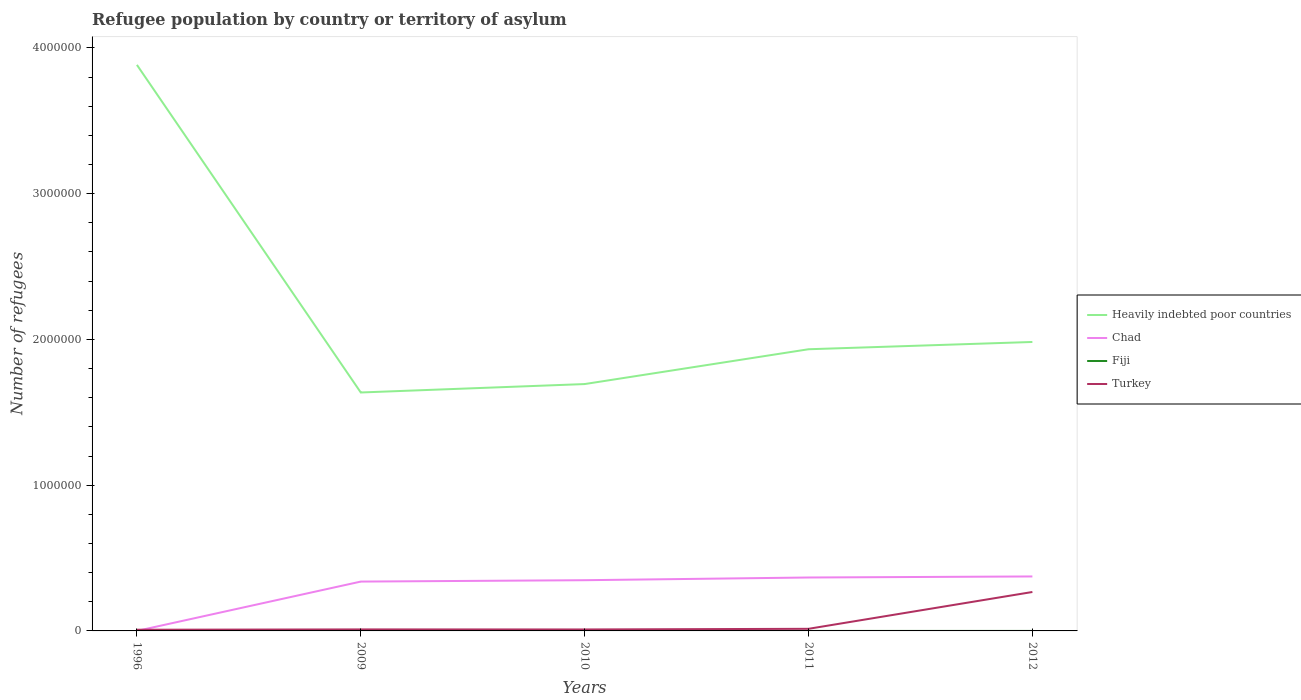How many different coloured lines are there?
Keep it short and to the point. 4. Does the line corresponding to Turkey intersect with the line corresponding to Heavily indebted poor countries?
Make the answer very short. No. Is the number of lines equal to the number of legend labels?
Your response must be concise. Yes. In which year was the number of refugees in Heavily indebted poor countries maximum?
Offer a terse response. 2009. What is the total number of refugees in Chad in the graph?
Your answer should be compact. -2.80e+04. What is the difference between the highest and the second highest number of refugees in Chad?
Keep it short and to the point. 3.74e+05. What is the difference between the highest and the lowest number of refugees in Chad?
Give a very brief answer. 4. Is the number of refugees in Fiji strictly greater than the number of refugees in Heavily indebted poor countries over the years?
Provide a short and direct response. Yes. How many lines are there?
Keep it short and to the point. 4. How many years are there in the graph?
Offer a very short reply. 5. Does the graph contain any zero values?
Give a very brief answer. No. Where does the legend appear in the graph?
Make the answer very short. Center right. How many legend labels are there?
Ensure brevity in your answer.  4. What is the title of the graph?
Offer a very short reply. Refugee population by country or territory of asylum. Does "Burkina Faso" appear as one of the legend labels in the graph?
Make the answer very short. No. What is the label or title of the Y-axis?
Your response must be concise. Number of refugees. What is the Number of refugees of Heavily indebted poor countries in 1996?
Your response must be concise. 3.88e+06. What is the Number of refugees in Fiji in 1996?
Your response must be concise. 9. What is the Number of refugees in Turkey in 1996?
Offer a very short reply. 8166. What is the Number of refugees in Heavily indebted poor countries in 2009?
Provide a short and direct response. 1.64e+06. What is the Number of refugees in Chad in 2009?
Offer a very short reply. 3.38e+05. What is the Number of refugees in Fiji in 2009?
Offer a terse response. 2. What is the Number of refugees of Turkey in 2009?
Your answer should be very brief. 1.04e+04. What is the Number of refugees of Heavily indebted poor countries in 2010?
Your response must be concise. 1.69e+06. What is the Number of refugees of Chad in 2010?
Your response must be concise. 3.48e+05. What is the Number of refugees in Turkey in 2010?
Make the answer very short. 1.00e+04. What is the Number of refugees of Heavily indebted poor countries in 2011?
Keep it short and to the point. 1.93e+06. What is the Number of refugees in Chad in 2011?
Give a very brief answer. 3.66e+05. What is the Number of refugees of Fiji in 2011?
Your answer should be compact. 7. What is the Number of refugees of Turkey in 2011?
Provide a succinct answer. 1.45e+04. What is the Number of refugees in Heavily indebted poor countries in 2012?
Keep it short and to the point. 1.98e+06. What is the Number of refugees of Chad in 2012?
Ensure brevity in your answer.  3.74e+05. What is the Number of refugees of Fiji in 2012?
Make the answer very short. 6. What is the Number of refugees in Turkey in 2012?
Offer a terse response. 2.67e+05. Across all years, what is the maximum Number of refugees in Heavily indebted poor countries?
Offer a very short reply. 3.88e+06. Across all years, what is the maximum Number of refugees of Chad?
Offer a very short reply. 3.74e+05. Across all years, what is the maximum Number of refugees in Turkey?
Provide a short and direct response. 2.67e+05. Across all years, what is the minimum Number of refugees of Heavily indebted poor countries?
Provide a succinct answer. 1.64e+06. Across all years, what is the minimum Number of refugees of Chad?
Give a very brief answer. 100. Across all years, what is the minimum Number of refugees in Turkey?
Ensure brevity in your answer.  8166. What is the total Number of refugees in Heavily indebted poor countries in the graph?
Keep it short and to the point. 1.11e+07. What is the total Number of refugees in Chad in the graph?
Your answer should be compact. 1.43e+06. What is the total Number of refugees in Turkey in the graph?
Your response must be concise. 3.10e+05. What is the difference between the Number of refugees in Heavily indebted poor countries in 1996 and that in 2009?
Provide a succinct answer. 2.25e+06. What is the difference between the Number of refugees of Chad in 1996 and that in 2009?
Your answer should be compact. -3.38e+05. What is the difference between the Number of refugees of Fiji in 1996 and that in 2009?
Offer a very short reply. 7. What is the difference between the Number of refugees of Turkey in 1996 and that in 2009?
Make the answer very short. -2184. What is the difference between the Number of refugees of Heavily indebted poor countries in 1996 and that in 2010?
Give a very brief answer. 2.19e+06. What is the difference between the Number of refugees of Chad in 1996 and that in 2010?
Your answer should be very brief. -3.48e+05. What is the difference between the Number of refugees in Turkey in 1996 and that in 2010?
Offer a terse response. -1866. What is the difference between the Number of refugees of Heavily indebted poor countries in 1996 and that in 2011?
Offer a terse response. 1.95e+06. What is the difference between the Number of refugees of Chad in 1996 and that in 2011?
Offer a very short reply. -3.66e+05. What is the difference between the Number of refugees of Fiji in 1996 and that in 2011?
Ensure brevity in your answer.  2. What is the difference between the Number of refugees in Turkey in 1996 and that in 2011?
Your response must be concise. -6299. What is the difference between the Number of refugees of Heavily indebted poor countries in 1996 and that in 2012?
Give a very brief answer. 1.90e+06. What is the difference between the Number of refugees in Chad in 1996 and that in 2012?
Give a very brief answer. -3.74e+05. What is the difference between the Number of refugees of Turkey in 1996 and that in 2012?
Provide a succinct answer. -2.59e+05. What is the difference between the Number of refugees in Heavily indebted poor countries in 2009 and that in 2010?
Your answer should be compact. -5.78e+04. What is the difference between the Number of refugees in Chad in 2009 and that in 2010?
Offer a terse response. -9444. What is the difference between the Number of refugees of Turkey in 2009 and that in 2010?
Provide a succinct answer. 318. What is the difference between the Number of refugees in Heavily indebted poor countries in 2009 and that in 2011?
Give a very brief answer. -2.97e+05. What is the difference between the Number of refugees in Chad in 2009 and that in 2011?
Provide a short and direct response. -2.80e+04. What is the difference between the Number of refugees of Turkey in 2009 and that in 2011?
Your answer should be compact. -4115. What is the difference between the Number of refugees in Heavily indebted poor countries in 2009 and that in 2012?
Ensure brevity in your answer.  -3.47e+05. What is the difference between the Number of refugees in Chad in 2009 and that in 2012?
Ensure brevity in your answer.  -3.52e+04. What is the difference between the Number of refugees in Turkey in 2009 and that in 2012?
Make the answer very short. -2.57e+05. What is the difference between the Number of refugees of Heavily indebted poor countries in 2010 and that in 2011?
Ensure brevity in your answer.  -2.39e+05. What is the difference between the Number of refugees in Chad in 2010 and that in 2011?
Ensure brevity in your answer.  -1.86e+04. What is the difference between the Number of refugees in Fiji in 2010 and that in 2011?
Your response must be concise. -6. What is the difference between the Number of refugees of Turkey in 2010 and that in 2011?
Your answer should be very brief. -4433. What is the difference between the Number of refugees in Heavily indebted poor countries in 2010 and that in 2012?
Your response must be concise. -2.89e+05. What is the difference between the Number of refugees in Chad in 2010 and that in 2012?
Give a very brief answer. -2.58e+04. What is the difference between the Number of refugees of Fiji in 2010 and that in 2012?
Offer a terse response. -5. What is the difference between the Number of refugees of Turkey in 2010 and that in 2012?
Keep it short and to the point. -2.57e+05. What is the difference between the Number of refugees of Heavily indebted poor countries in 2011 and that in 2012?
Offer a terse response. -5.00e+04. What is the difference between the Number of refugees of Chad in 2011 and that in 2012?
Your response must be concise. -7201. What is the difference between the Number of refugees of Turkey in 2011 and that in 2012?
Your response must be concise. -2.53e+05. What is the difference between the Number of refugees in Heavily indebted poor countries in 1996 and the Number of refugees in Chad in 2009?
Make the answer very short. 3.54e+06. What is the difference between the Number of refugees in Heavily indebted poor countries in 1996 and the Number of refugees in Fiji in 2009?
Offer a very short reply. 3.88e+06. What is the difference between the Number of refugees in Heavily indebted poor countries in 1996 and the Number of refugees in Turkey in 2009?
Your answer should be compact. 3.87e+06. What is the difference between the Number of refugees in Chad in 1996 and the Number of refugees in Fiji in 2009?
Offer a very short reply. 98. What is the difference between the Number of refugees in Chad in 1996 and the Number of refugees in Turkey in 2009?
Give a very brief answer. -1.02e+04. What is the difference between the Number of refugees in Fiji in 1996 and the Number of refugees in Turkey in 2009?
Give a very brief answer. -1.03e+04. What is the difference between the Number of refugees of Heavily indebted poor countries in 1996 and the Number of refugees of Chad in 2010?
Your answer should be very brief. 3.54e+06. What is the difference between the Number of refugees of Heavily indebted poor countries in 1996 and the Number of refugees of Fiji in 2010?
Make the answer very short. 3.88e+06. What is the difference between the Number of refugees in Heavily indebted poor countries in 1996 and the Number of refugees in Turkey in 2010?
Ensure brevity in your answer.  3.87e+06. What is the difference between the Number of refugees in Chad in 1996 and the Number of refugees in Fiji in 2010?
Your response must be concise. 99. What is the difference between the Number of refugees in Chad in 1996 and the Number of refugees in Turkey in 2010?
Provide a short and direct response. -9932. What is the difference between the Number of refugees in Fiji in 1996 and the Number of refugees in Turkey in 2010?
Provide a succinct answer. -1.00e+04. What is the difference between the Number of refugees in Heavily indebted poor countries in 1996 and the Number of refugees in Chad in 2011?
Offer a very short reply. 3.52e+06. What is the difference between the Number of refugees in Heavily indebted poor countries in 1996 and the Number of refugees in Fiji in 2011?
Keep it short and to the point. 3.88e+06. What is the difference between the Number of refugees in Heavily indebted poor countries in 1996 and the Number of refugees in Turkey in 2011?
Your answer should be very brief. 3.87e+06. What is the difference between the Number of refugees in Chad in 1996 and the Number of refugees in Fiji in 2011?
Provide a succinct answer. 93. What is the difference between the Number of refugees of Chad in 1996 and the Number of refugees of Turkey in 2011?
Ensure brevity in your answer.  -1.44e+04. What is the difference between the Number of refugees of Fiji in 1996 and the Number of refugees of Turkey in 2011?
Provide a short and direct response. -1.45e+04. What is the difference between the Number of refugees of Heavily indebted poor countries in 1996 and the Number of refugees of Chad in 2012?
Ensure brevity in your answer.  3.51e+06. What is the difference between the Number of refugees in Heavily indebted poor countries in 1996 and the Number of refugees in Fiji in 2012?
Ensure brevity in your answer.  3.88e+06. What is the difference between the Number of refugees of Heavily indebted poor countries in 1996 and the Number of refugees of Turkey in 2012?
Provide a succinct answer. 3.62e+06. What is the difference between the Number of refugees of Chad in 1996 and the Number of refugees of Fiji in 2012?
Your answer should be very brief. 94. What is the difference between the Number of refugees of Chad in 1996 and the Number of refugees of Turkey in 2012?
Provide a succinct answer. -2.67e+05. What is the difference between the Number of refugees in Fiji in 1996 and the Number of refugees in Turkey in 2012?
Keep it short and to the point. -2.67e+05. What is the difference between the Number of refugees of Heavily indebted poor countries in 2009 and the Number of refugees of Chad in 2010?
Ensure brevity in your answer.  1.29e+06. What is the difference between the Number of refugees in Heavily indebted poor countries in 2009 and the Number of refugees in Fiji in 2010?
Make the answer very short. 1.64e+06. What is the difference between the Number of refugees of Heavily indebted poor countries in 2009 and the Number of refugees of Turkey in 2010?
Keep it short and to the point. 1.63e+06. What is the difference between the Number of refugees in Chad in 2009 and the Number of refugees in Fiji in 2010?
Your answer should be compact. 3.38e+05. What is the difference between the Number of refugees in Chad in 2009 and the Number of refugees in Turkey in 2010?
Provide a succinct answer. 3.28e+05. What is the difference between the Number of refugees of Fiji in 2009 and the Number of refugees of Turkey in 2010?
Make the answer very short. -1.00e+04. What is the difference between the Number of refugees of Heavily indebted poor countries in 2009 and the Number of refugees of Chad in 2011?
Make the answer very short. 1.27e+06. What is the difference between the Number of refugees in Heavily indebted poor countries in 2009 and the Number of refugees in Fiji in 2011?
Your response must be concise. 1.64e+06. What is the difference between the Number of refugees in Heavily indebted poor countries in 2009 and the Number of refugees in Turkey in 2011?
Provide a short and direct response. 1.62e+06. What is the difference between the Number of refugees of Chad in 2009 and the Number of refugees of Fiji in 2011?
Provide a succinct answer. 3.38e+05. What is the difference between the Number of refugees of Chad in 2009 and the Number of refugees of Turkey in 2011?
Offer a terse response. 3.24e+05. What is the difference between the Number of refugees in Fiji in 2009 and the Number of refugees in Turkey in 2011?
Offer a very short reply. -1.45e+04. What is the difference between the Number of refugees in Heavily indebted poor countries in 2009 and the Number of refugees in Chad in 2012?
Make the answer very short. 1.26e+06. What is the difference between the Number of refugees of Heavily indebted poor countries in 2009 and the Number of refugees of Fiji in 2012?
Ensure brevity in your answer.  1.64e+06. What is the difference between the Number of refugees in Heavily indebted poor countries in 2009 and the Number of refugees in Turkey in 2012?
Provide a short and direct response. 1.37e+06. What is the difference between the Number of refugees in Chad in 2009 and the Number of refugees in Fiji in 2012?
Offer a terse response. 3.38e+05. What is the difference between the Number of refugees in Chad in 2009 and the Number of refugees in Turkey in 2012?
Offer a very short reply. 7.14e+04. What is the difference between the Number of refugees of Fiji in 2009 and the Number of refugees of Turkey in 2012?
Make the answer very short. -2.67e+05. What is the difference between the Number of refugees of Heavily indebted poor countries in 2010 and the Number of refugees of Chad in 2011?
Offer a terse response. 1.33e+06. What is the difference between the Number of refugees in Heavily indebted poor countries in 2010 and the Number of refugees in Fiji in 2011?
Your response must be concise. 1.69e+06. What is the difference between the Number of refugees in Heavily indebted poor countries in 2010 and the Number of refugees in Turkey in 2011?
Make the answer very short. 1.68e+06. What is the difference between the Number of refugees of Chad in 2010 and the Number of refugees of Fiji in 2011?
Offer a very short reply. 3.48e+05. What is the difference between the Number of refugees in Chad in 2010 and the Number of refugees in Turkey in 2011?
Provide a succinct answer. 3.33e+05. What is the difference between the Number of refugees of Fiji in 2010 and the Number of refugees of Turkey in 2011?
Your answer should be very brief. -1.45e+04. What is the difference between the Number of refugees of Heavily indebted poor countries in 2010 and the Number of refugees of Chad in 2012?
Your response must be concise. 1.32e+06. What is the difference between the Number of refugees of Heavily indebted poor countries in 2010 and the Number of refugees of Fiji in 2012?
Make the answer very short. 1.69e+06. What is the difference between the Number of refugees of Heavily indebted poor countries in 2010 and the Number of refugees of Turkey in 2012?
Ensure brevity in your answer.  1.43e+06. What is the difference between the Number of refugees in Chad in 2010 and the Number of refugees in Fiji in 2012?
Provide a short and direct response. 3.48e+05. What is the difference between the Number of refugees of Chad in 2010 and the Number of refugees of Turkey in 2012?
Make the answer very short. 8.09e+04. What is the difference between the Number of refugees in Fiji in 2010 and the Number of refugees in Turkey in 2012?
Keep it short and to the point. -2.67e+05. What is the difference between the Number of refugees in Heavily indebted poor countries in 2011 and the Number of refugees in Chad in 2012?
Ensure brevity in your answer.  1.56e+06. What is the difference between the Number of refugees in Heavily indebted poor countries in 2011 and the Number of refugees in Fiji in 2012?
Offer a very short reply. 1.93e+06. What is the difference between the Number of refugees of Heavily indebted poor countries in 2011 and the Number of refugees of Turkey in 2012?
Offer a terse response. 1.67e+06. What is the difference between the Number of refugees in Chad in 2011 and the Number of refugees in Fiji in 2012?
Your response must be concise. 3.66e+05. What is the difference between the Number of refugees of Chad in 2011 and the Number of refugees of Turkey in 2012?
Offer a very short reply. 9.94e+04. What is the difference between the Number of refugees in Fiji in 2011 and the Number of refugees in Turkey in 2012?
Provide a succinct answer. -2.67e+05. What is the average Number of refugees in Heavily indebted poor countries per year?
Your response must be concise. 2.23e+06. What is the average Number of refugees in Chad per year?
Make the answer very short. 2.85e+05. What is the average Number of refugees in Turkey per year?
Your answer should be very brief. 6.20e+04. In the year 1996, what is the difference between the Number of refugees in Heavily indebted poor countries and Number of refugees in Chad?
Your answer should be compact. 3.88e+06. In the year 1996, what is the difference between the Number of refugees in Heavily indebted poor countries and Number of refugees in Fiji?
Keep it short and to the point. 3.88e+06. In the year 1996, what is the difference between the Number of refugees in Heavily indebted poor countries and Number of refugees in Turkey?
Provide a succinct answer. 3.88e+06. In the year 1996, what is the difference between the Number of refugees in Chad and Number of refugees in Fiji?
Give a very brief answer. 91. In the year 1996, what is the difference between the Number of refugees of Chad and Number of refugees of Turkey?
Give a very brief answer. -8066. In the year 1996, what is the difference between the Number of refugees of Fiji and Number of refugees of Turkey?
Provide a short and direct response. -8157. In the year 2009, what is the difference between the Number of refugees of Heavily indebted poor countries and Number of refugees of Chad?
Your response must be concise. 1.30e+06. In the year 2009, what is the difference between the Number of refugees in Heavily indebted poor countries and Number of refugees in Fiji?
Your response must be concise. 1.64e+06. In the year 2009, what is the difference between the Number of refugees in Heavily indebted poor countries and Number of refugees in Turkey?
Make the answer very short. 1.63e+06. In the year 2009, what is the difference between the Number of refugees in Chad and Number of refugees in Fiji?
Provide a short and direct response. 3.38e+05. In the year 2009, what is the difference between the Number of refugees in Chad and Number of refugees in Turkey?
Your response must be concise. 3.28e+05. In the year 2009, what is the difference between the Number of refugees in Fiji and Number of refugees in Turkey?
Offer a very short reply. -1.03e+04. In the year 2010, what is the difference between the Number of refugees of Heavily indebted poor countries and Number of refugees of Chad?
Your response must be concise. 1.35e+06. In the year 2010, what is the difference between the Number of refugees in Heavily indebted poor countries and Number of refugees in Fiji?
Give a very brief answer. 1.69e+06. In the year 2010, what is the difference between the Number of refugees of Heavily indebted poor countries and Number of refugees of Turkey?
Offer a terse response. 1.68e+06. In the year 2010, what is the difference between the Number of refugees of Chad and Number of refugees of Fiji?
Ensure brevity in your answer.  3.48e+05. In the year 2010, what is the difference between the Number of refugees of Chad and Number of refugees of Turkey?
Make the answer very short. 3.38e+05. In the year 2010, what is the difference between the Number of refugees of Fiji and Number of refugees of Turkey?
Offer a very short reply. -1.00e+04. In the year 2011, what is the difference between the Number of refugees of Heavily indebted poor countries and Number of refugees of Chad?
Offer a terse response. 1.57e+06. In the year 2011, what is the difference between the Number of refugees in Heavily indebted poor countries and Number of refugees in Fiji?
Provide a short and direct response. 1.93e+06. In the year 2011, what is the difference between the Number of refugees of Heavily indebted poor countries and Number of refugees of Turkey?
Your answer should be very brief. 1.92e+06. In the year 2011, what is the difference between the Number of refugees in Chad and Number of refugees in Fiji?
Provide a short and direct response. 3.66e+05. In the year 2011, what is the difference between the Number of refugees of Chad and Number of refugees of Turkey?
Ensure brevity in your answer.  3.52e+05. In the year 2011, what is the difference between the Number of refugees in Fiji and Number of refugees in Turkey?
Provide a short and direct response. -1.45e+04. In the year 2012, what is the difference between the Number of refugees of Heavily indebted poor countries and Number of refugees of Chad?
Ensure brevity in your answer.  1.61e+06. In the year 2012, what is the difference between the Number of refugees of Heavily indebted poor countries and Number of refugees of Fiji?
Offer a very short reply. 1.98e+06. In the year 2012, what is the difference between the Number of refugees in Heavily indebted poor countries and Number of refugees in Turkey?
Ensure brevity in your answer.  1.72e+06. In the year 2012, what is the difference between the Number of refugees in Chad and Number of refugees in Fiji?
Provide a succinct answer. 3.74e+05. In the year 2012, what is the difference between the Number of refugees of Chad and Number of refugees of Turkey?
Your answer should be compact. 1.07e+05. In the year 2012, what is the difference between the Number of refugees in Fiji and Number of refugees in Turkey?
Offer a terse response. -2.67e+05. What is the ratio of the Number of refugees in Heavily indebted poor countries in 1996 to that in 2009?
Make the answer very short. 2.37. What is the ratio of the Number of refugees of Chad in 1996 to that in 2009?
Provide a succinct answer. 0. What is the ratio of the Number of refugees of Turkey in 1996 to that in 2009?
Ensure brevity in your answer.  0.79. What is the ratio of the Number of refugees of Heavily indebted poor countries in 1996 to that in 2010?
Offer a very short reply. 2.29. What is the ratio of the Number of refugees of Fiji in 1996 to that in 2010?
Make the answer very short. 9. What is the ratio of the Number of refugees in Turkey in 1996 to that in 2010?
Ensure brevity in your answer.  0.81. What is the ratio of the Number of refugees of Heavily indebted poor countries in 1996 to that in 2011?
Your response must be concise. 2.01. What is the ratio of the Number of refugees in Chad in 1996 to that in 2011?
Make the answer very short. 0. What is the ratio of the Number of refugees in Turkey in 1996 to that in 2011?
Keep it short and to the point. 0.56. What is the ratio of the Number of refugees in Heavily indebted poor countries in 1996 to that in 2012?
Make the answer very short. 1.96. What is the ratio of the Number of refugees of Turkey in 1996 to that in 2012?
Ensure brevity in your answer.  0.03. What is the ratio of the Number of refugees of Heavily indebted poor countries in 2009 to that in 2010?
Ensure brevity in your answer.  0.97. What is the ratio of the Number of refugees of Chad in 2009 to that in 2010?
Make the answer very short. 0.97. What is the ratio of the Number of refugees of Turkey in 2009 to that in 2010?
Keep it short and to the point. 1.03. What is the ratio of the Number of refugees of Heavily indebted poor countries in 2009 to that in 2011?
Your answer should be very brief. 0.85. What is the ratio of the Number of refugees of Chad in 2009 to that in 2011?
Provide a succinct answer. 0.92. What is the ratio of the Number of refugees of Fiji in 2009 to that in 2011?
Offer a terse response. 0.29. What is the ratio of the Number of refugees in Turkey in 2009 to that in 2011?
Your answer should be compact. 0.72. What is the ratio of the Number of refugees of Heavily indebted poor countries in 2009 to that in 2012?
Give a very brief answer. 0.83. What is the ratio of the Number of refugees of Chad in 2009 to that in 2012?
Your answer should be compact. 0.91. What is the ratio of the Number of refugees in Turkey in 2009 to that in 2012?
Keep it short and to the point. 0.04. What is the ratio of the Number of refugees in Heavily indebted poor countries in 2010 to that in 2011?
Ensure brevity in your answer.  0.88. What is the ratio of the Number of refugees of Chad in 2010 to that in 2011?
Offer a terse response. 0.95. What is the ratio of the Number of refugees of Fiji in 2010 to that in 2011?
Your answer should be compact. 0.14. What is the ratio of the Number of refugees of Turkey in 2010 to that in 2011?
Your response must be concise. 0.69. What is the ratio of the Number of refugees in Heavily indebted poor countries in 2010 to that in 2012?
Keep it short and to the point. 0.85. What is the ratio of the Number of refugees of Chad in 2010 to that in 2012?
Offer a very short reply. 0.93. What is the ratio of the Number of refugees of Fiji in 2010 to that in 2012?
Your answer should be very brief. 0.17. What is the ratio of the Number of refugees in Turkey in 2010 to that in 2012?
Ensure brevity in your answer.  0.04. What is the ratio of the Number of refugees of Heavily indebted poor countries in 2011 to that in 2012?
Provide a short and direct response. 0.97. What is the ratio of the Number of refugees of Chad in 2011 to that in 2012?
Your response must be concise. 0.98. What is the ratio of the Number of refugees in Fiji in 2011 to that in 2012?
Ensure brevity in your answer.  1.17. What is the ratio of the Number of refugees of Turkey in 2011 to that in 2012?
Offer a terse response. 0.05. What is the difference between the highest and the second highest Number of refugees in Heavily indebted poor countries?
Offer a terse response. 1.90e+06. What is the difference between the highest and the second highest Number of refugees in Chad?
Give a very brief answer. 7201. What is the difference between the highest and the second highest Number of refugees of Fiji?
Your answer should be very brief. 2. What is the difference between the highest and the second highest Number of refugees in Turkey?
Make the answer very short. 2.53e+05. What is the difference between the highest and the lowest Number of refugees in Heavily indebted poor countries?
Provide a short and direct response. 2.25e+06. What is the difference between the highest and the lowest Number of refugees of Chad?
Your answer should be very brief. 3.74e+05. What is the difference between the highest and the lowest Number of refugees of Fiji?
Keep it short and to the point. 8. What is the difference between the highest and the lowest Number of refugees in Turkey?
Provide a succinct answer. 2.59e+05. 